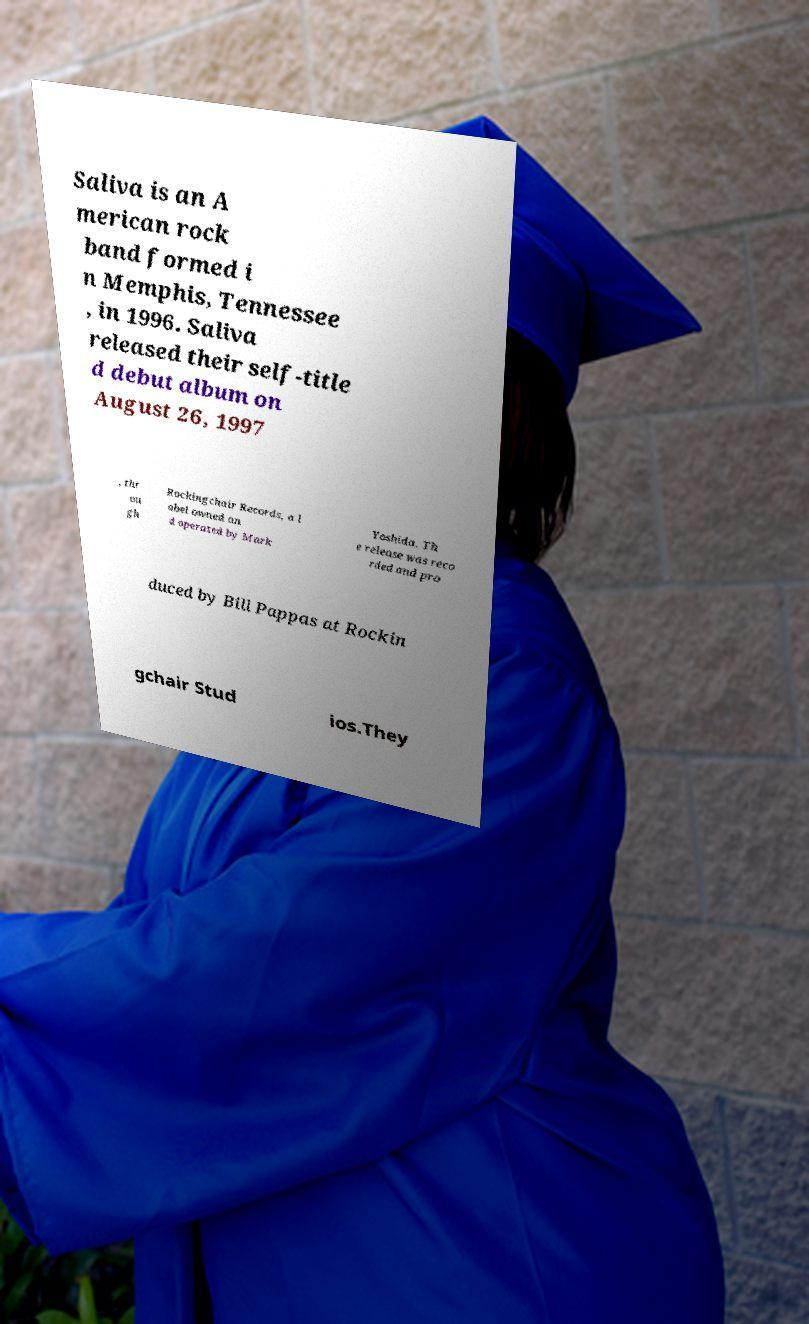Could you assist in decoding the text presented in this image and type it out clearly? Saliva is an A merican rock band formed i n Memphis, Tennessee , in 1996. Saliva released their self-title d debut album on August 26, 1997 , thr ou gh Rockingchair Records, a l abel owned an d operated by Mark Yoshida. Th e release was reco rded and pro duced by Bill Pappas at Rockin gchair Stud ios.They 